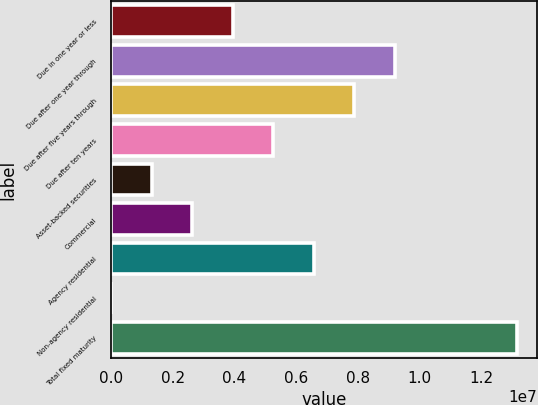Convert chart to OTSL. <chart><loc_0><loc_0><loc_500><loc_500><bar_chart><fcel>Due in one year or less<fcel>Due after one year through<fcel>Due after five years through<fcel>Due after ten years<fcel>Asset-backed securities<fcel>Commercial<fcel>Agency residential<fcel>Non-agency residential<fcel>Total fixed maturity<nl><fcel>3.94813e+06<fcel>9.20157e+06<fcel>7.88821e+06<fcel>5.26149e+06<fcel>1.32141e+06<fcel>2.63477e+06<fcel>6.57485e+06<fcel>8049<fcel>1.31417e+07<nl></chart> 